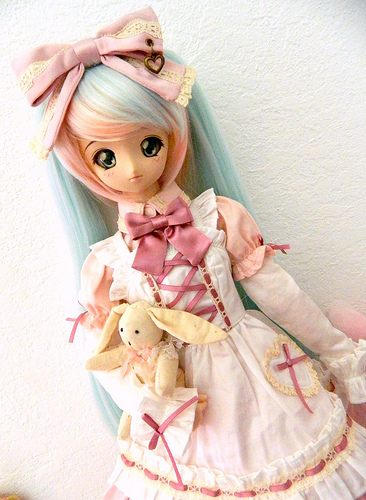<image>
Is the rabbit under the bow? Yes. The rabbit is positioned underneath the bow, with the bow above it in the vertical space. Is there a head behind the bow? No. The head is not behind the bow. From this viewpoint, the head appears to be positioned elsewhere in the scene. 